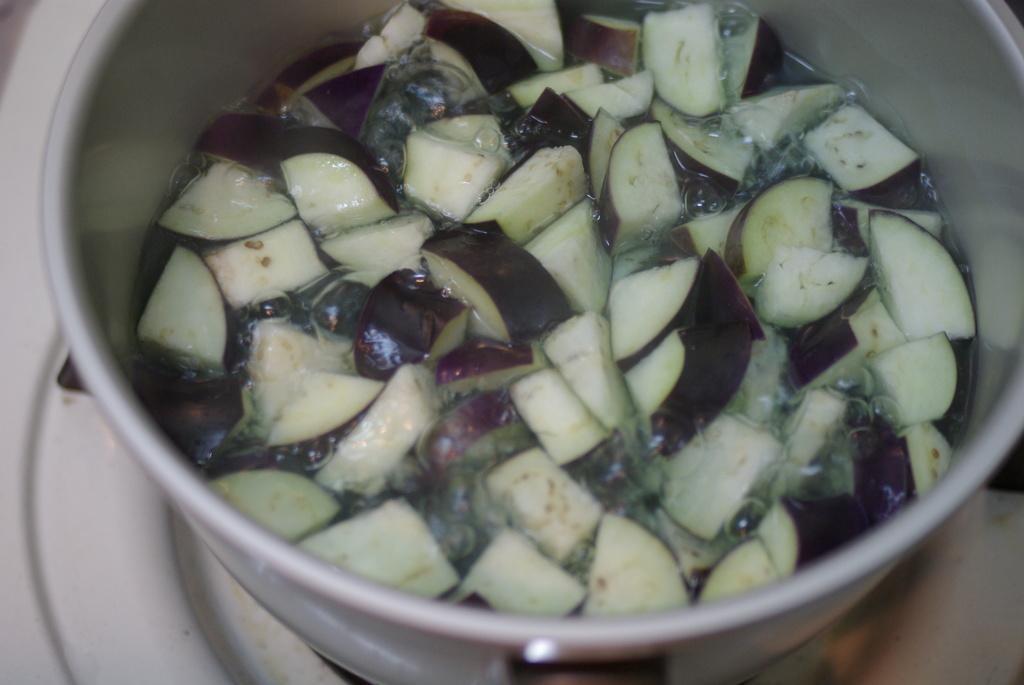Can you describe this image briefly? In this image we can see a bowl containing some water and pieces of vegetables which is placed on the surface. 